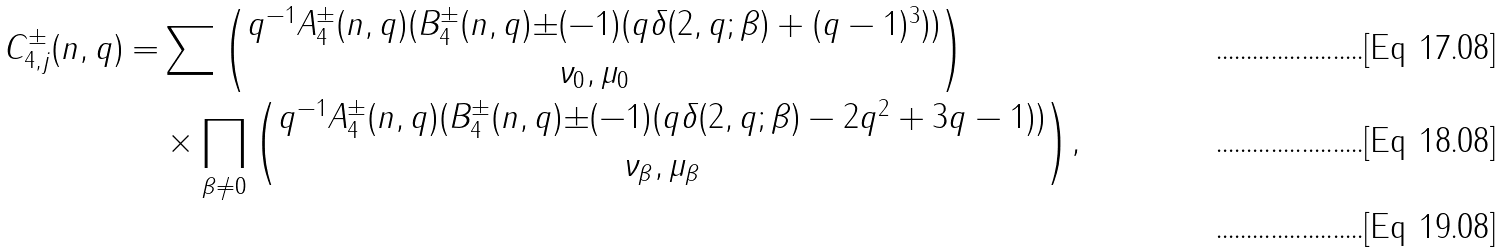Convert formula to latex. <formula><loc_0><loc_0><loc_500><loc_500>C _ { 4 , j } ^ { \pm } ( n , q ) = & \sum { \binom { q ^ { - 1 } A _ { 4 } ^ { \pm } ( n , q ) ( B _ { 4 } ^ { \pm } ( n , q ) { \pm } ( - 1 ) ( q \delta ( 2 , q ; \beta ) + ( q - 1 ) ^ { 3 } ) ) } { \nu _ { 0 } , \mu _ { 0 } } } \\ & \times \prod _ { \beta \neq 0 } { \binom { q ^ { - 1 } A _ { 4 } ^ { \pm } ( n , q ) ( B _ { 4 } ^ { \pm } ( n , q ) { \pm } ( - 1 ) ( q \delta ( 2 , q ; \beta ) - 2 q ^ { 2 } + 3 q - 1 ) ) } { \nu _ { \beta } , \mu _ { \beta } } } , \\</formula> 